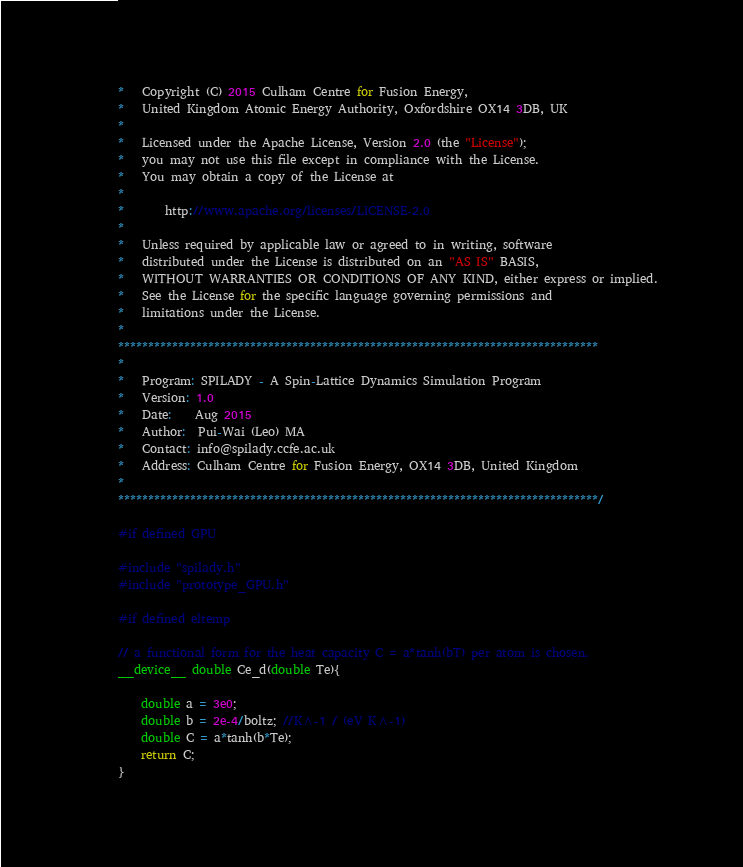Convert code to text. <code><loc_0><loc_0><loc_500><loc_500><_Cuda_>*   Copyright (C) 2015 Culham Centre for Fusion Energy,
*   United Kingdom Atomic Energy Authority, Oxfordshire OX14 3DB, UK
*
*   Licensed under the Apache License, Version 2.0 (the "License");
*   you may not use this file except in compliance with the License.
*   You may obtain a copy of the License at
*
*       http://www.apache.org/licenses/LICENSE-2.0
*
*   Unless required by applicable law or agreed to in writing, software
*   distributed under the License is distributed on an "AS IS" BASIS,
*   WITHOUT WARRANTIES OR CONDITIONS OF ANY KIND, either express or implied.
*   See the License for the specific language governing permissions and
*   limitations under the License.
*
********************************************************************************
*
*   Program: SPILADY - A Spin-Lattice Dynamics Simulation Program
*   Version: 1.0
*   Date:    Aug 2015
*   Author:  Pui-Wai (Leo) MA
*   Contact: info@spilady.ccfe.ac.uk
*   Address: Culham Centre for Fusion Energy, OX14 3DB, United Kingdom
*
********************************************************************************/

#if defined GPU

#include "spilady.h"
#include "prototype_GPU.h"

#if defined eltemp

// a functional form for the heat capacity C = a*tanh(bT) per atom is chosen.
__device__ double Ce_d(double Te){

    double a = 3e0;
    double b = 2e-4/boltz; //K^-1 / (eV K^-1)
    double C = a*tanh(b*Te);
    return C;
}
</code> 